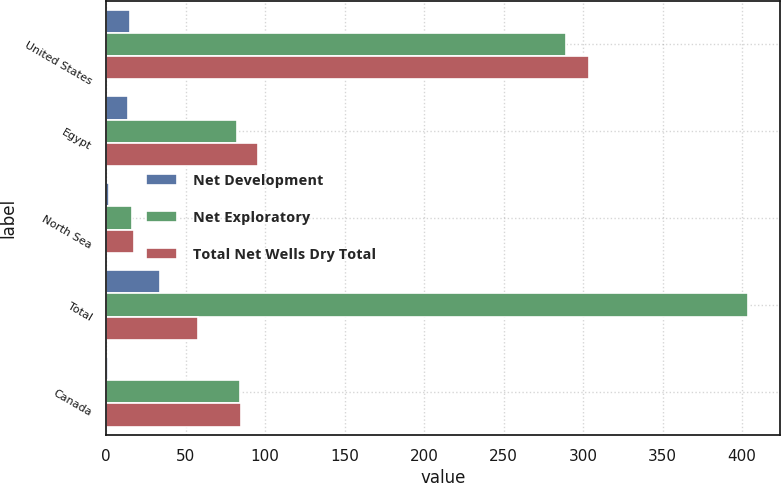<chart> <loc_0><loc_0><loc_500><loc_500><stacked_bar_chart><ecel><fcel>United States<fcel>Egypt<fcel>North Sea<fcel>Total<fcel>Canada<nl><fcel>Net Development<fcel>14.7<fcel>13.4<fcel>1.6<fcel>33.7<fcel>1<nl><fcel>Net Exploratory<fcel>289<fcel>82.3<fcel>15.9<fcel>403.9<fcel>83.9<nl><fcel>Total Net Wells Dry Total<fcel>303.7<fcel>95.7<fcel>17.5<fcel>58<fcel>84.9<nl></chart> 